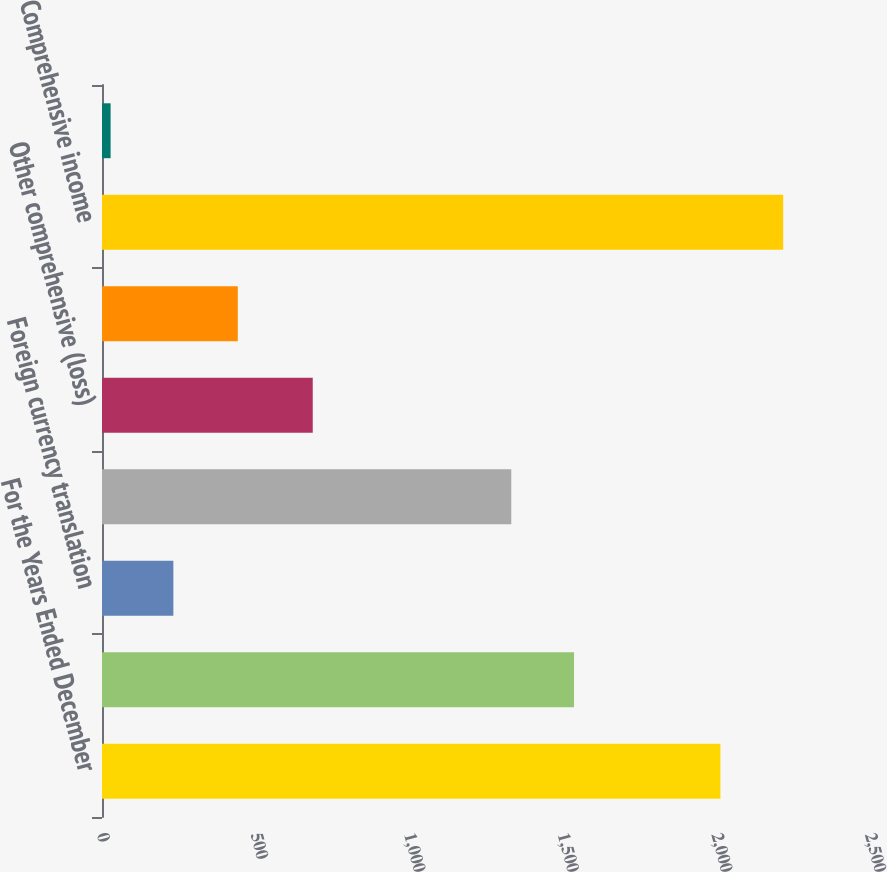Convert chart to OTSL. <chart><loc_0><loc_0><loc_500><loc_500><bar_chart><fcel>For the Years Ended December<fcel>Net income before<fcel>Foreign currency translation<fcel>Gain (loss) related to<fcel>Other comprehensive (loss)<fcel>Income tax expense (credit) on<fcel>Comprehensive income<fcel>Less Comprehensive income<nl><fcel>2013<fcel>1536.6<fcel>232.3<fcel>1332.3<fcel>686<fcel>442<fcel>2217.3<fcel>28<nl></chart> 